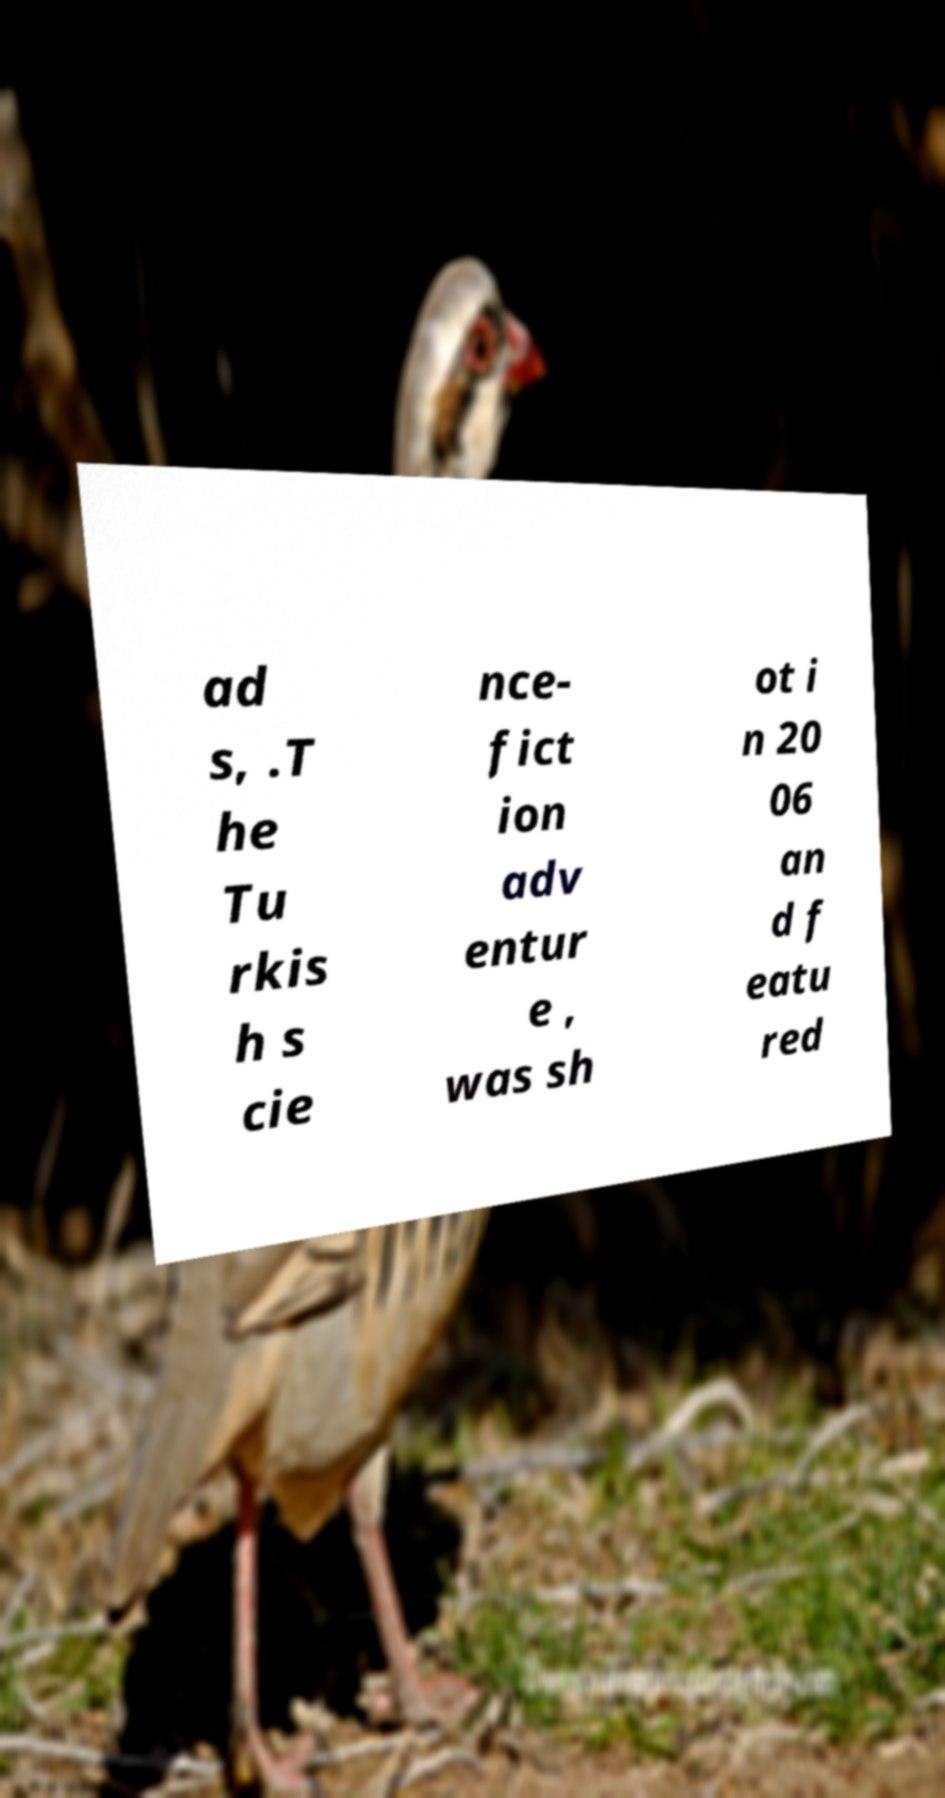For documentation purposes, I need the text within this image transcribed. Could you provide that? ad s, .T he Tu rkis h s cie nce- fict ion adv entur e , was sh ot i n 20 06 an d f eatu red 